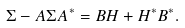<formula> <loc_0><loc_0><loc_500><loc_500>\Sigma - A \Sigma A ^ { \ast } = B H + H ^ { \ast } B ^ { \ast } .</formula> 